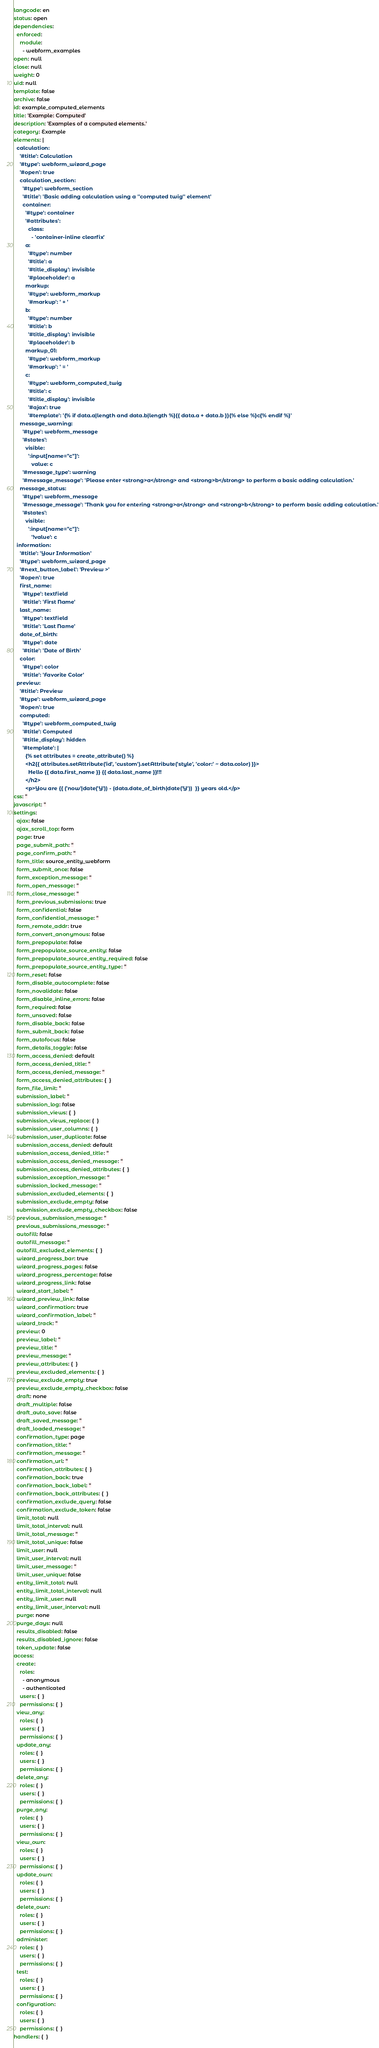Convert code to text. <code><loc_0><loc_0><loc_500><loc_500><_YAML_>langcode: en
status: open
dependencies:
  enforced:
    module:
      - webform_examples
open: null
close: null
weight: 0
uid: null
template: false
archive: false
id: example_computed_elements
title: 'Example: Computed'
description: 'Examples of a computed elements.'
category: Example
elements: |
  calculation:
    '#title': Calculation
    '#type': webform_wizard_page
    '#open': true
    calculation_section:
      '#type': webform_section
      '#title': 'Basic adding calculation using a ''computed twig'' element'
      container:
        '#type': container
        '#attributes':
          class:
            - 'container-inline clearfix'
        a:
          '#type': number
          '#title': a
          '#title_display': invisible
          '#placeholder': a
        markup:
          '#type': webform_markup
          '#markup': ' + '
        b:
          '#type': number
          '#title': b
          '#title_display': invisible
          '#placeholder': b
        markup_01:
          '#type': webform_markup
          '#markup': ' = '
        c:
          '#type': webform_computed_twig
          '#title': c
          '#title_display': invisible
          '#ajax': true
          '#template': '{% if data.a|length and data.b|length %}{{ data.a + data.b }}{% else %}c{% endif %}'
    message_warning:
      '#type': webform_message
      '#states':
        visible:
          ':input[name="c"]':
            value: c
      '#message_type': warning
      '#message_message': 'Please enter <strong>a</strong> and <strong>b</strong> to perform a basic adding calculation.'
    message_status:
      '#type': webform_message
      '#message_message': 'Thank you for entering <strong>a</strong> and <strong>b</strong> to perform basic adding calculation.'
      '#states':
        visible:
          ':input[name="c"]':
            '!value': c
  information:
    '#title': 'Your Information'
    '#type': webform_wizard_page
    '#next_button_label': 'Preview >'
    '#open': true
    first_name:
      '#type': textfield
      '#title': 'First Name'
    last_name:
      '#type': textfield
      '#title': 'Last Name'
    date_of_birth:
      '#type': date
      '#title': 'Date of Birth'
    color:
      '#type': color
      '#title': 'Favorite Color'
  preview:
    '#title': Preview
    '#type': webform_wizard_page
    '#open': true
    computed:
      '#type': webform_computed_twig
      '#title': Computed
      '#title_display': hidden
      '#template': |
        {% set attributes = create_attribute() %}
        <h2{{ attributes.setAttribute('id', 'custom').setAttribute('style', 'color:' ~ data.color) }}>
          Hello {{ data.first_name }} {{ data.last_name }}!!!
        </h2>
        <p>You are {{ ('now'|date('Y')) - (data.date_of_birth|date('Y'))  }} years old.</p>
css: ''
javascript: ''
settings:
  ajax: false
  ajax_scroll_top: form
  page: true
  page_submit_path: ''
  page_confirm_path: ''
  form_title: source_entity_webform
  form_submit_once: false
  form_exception_message: ''
  form_open_message: ''
  form_close_message: ''
  form_previous_submissions: true
  form_confidential: false
  form_confidential_message: ''
  form_remote_addr: true
  form_convert_anonymous: false
  form_prepopulate: false
  form_prepopulate_source_entity: false
  form_prepopulate_source_entity_required: false
  form_prepopulate_source_entity_type: ''
  form_reset: false
  form_disable_autocomplete: false
  form_novalidate: false
  form_disable_inline_errors: false
  form_required: false
  form_unsaved: false
  form_disable_back: false
  form_submit_back: false
  form_autofocus: false
  form_details_toggle: false
  form_access_denied: default
  form_access_denied_title: ''
  form_access_denied_message: ''
  form_access_denied_attributes: {  }
  form_file_limit: ''
  submission_label: ''
  submission_log: false
  submission_views: {  }
  submission_views_replace: {  }
  submission_user_columns: {  }
  submission_user_duplicate: false
  submission_access_denied: default
  submission_access_denied_title: ''
  submission_access_denied_message: ''
  submission_access_denied_attributes: {  }
  submission_exception_message: ''
  submission_locked_message: ''
  submission_excluded_elements: {  }
  submission_exclude_empty: false
  submission_exclude_empty_checkbox: false
  previous_submission_message: ''
  previous_submissions_message: ''
  autofill: false
  autofill_message: ''
  autofill_excluded_elements: {  }
  wizard_progress_bar: true
  wizard_progress_pages: false
  wizard_progress_percentage: false
  wizard_progress_link: false
  wizard_start_label: ''
  wizard_preview_link: false
  wizard_confirmation: true
  wizard_confirmation_label: ''
  wizard_track: ''
  preview: 0
  preview_label: ''
  preview_title: ''
  preview_message: ''
  preview_attributes: {  }
  preview_excluded_elements: {  }
  preview_exclude_empty: true
  preview_exclude_empty_checkbox: false
  draft: none
  draft_multiple: false
  draft_auto_save: false
  draft_saved_message: ''
  draft_loaded_message: ''
  confirmation_type: page
  confirmation_title: ''
  confirmation_message: ''
  confirmation_url: ''
  confirmation_attributes: {  }
  confirmation_back: true
  confirmation_back_label: ''
  confirmation_back_attributes: {  }
  confirmation_exclude_query: false
  confirmation_exclude_token: false
  limit_total: null
  limit_total_interval: null
  limit_total_message: ''
  limit_total_unique: false
  limit_user: null
  limit_user_interval: null
  limit_user_message: ''
  limit_user_unique: false
  entity_limit_total: null
  entity_limit_total_interval: null
  entity_limit_user: null
  entity_limit_user_interval: null
  purge: none
  purge_days: null
  results_disabled: false
  results_disabled_ignore: false
  token_update: false
access:
  create:
    roles:
      - anonymous
      - authenticated
    users: {  }
    permissions: {  }
  view_any:
    roles: {  }
    users: {  }
    permissions: {  }
  update_any:
    roles: {  }
    users: {  }
    permissions: {  }
  delete_any:
    roles: {  }
    users: {  }
    permissions: {  }
  purge_any:
    roles: {  }
    users: {  }
    permissions: {  }
  view_own:
    roles: {  }
    users: {  }
    permissions: {  }
  update_own:
    roles: {  }
    users: {  }
    permissions: {  }
  delete_own:
    roles: {  }
    users: {  }
    permissions: {  }
  administer:
    roles: {  }
    users: {  }
    permissions: {  }
  test:
    roles: {  }
    users: {  }
    permissions: {  }
  configuration:
    roles: {  }
    users: {  }
    permissions: {  }
handlers: {  }
</code> 